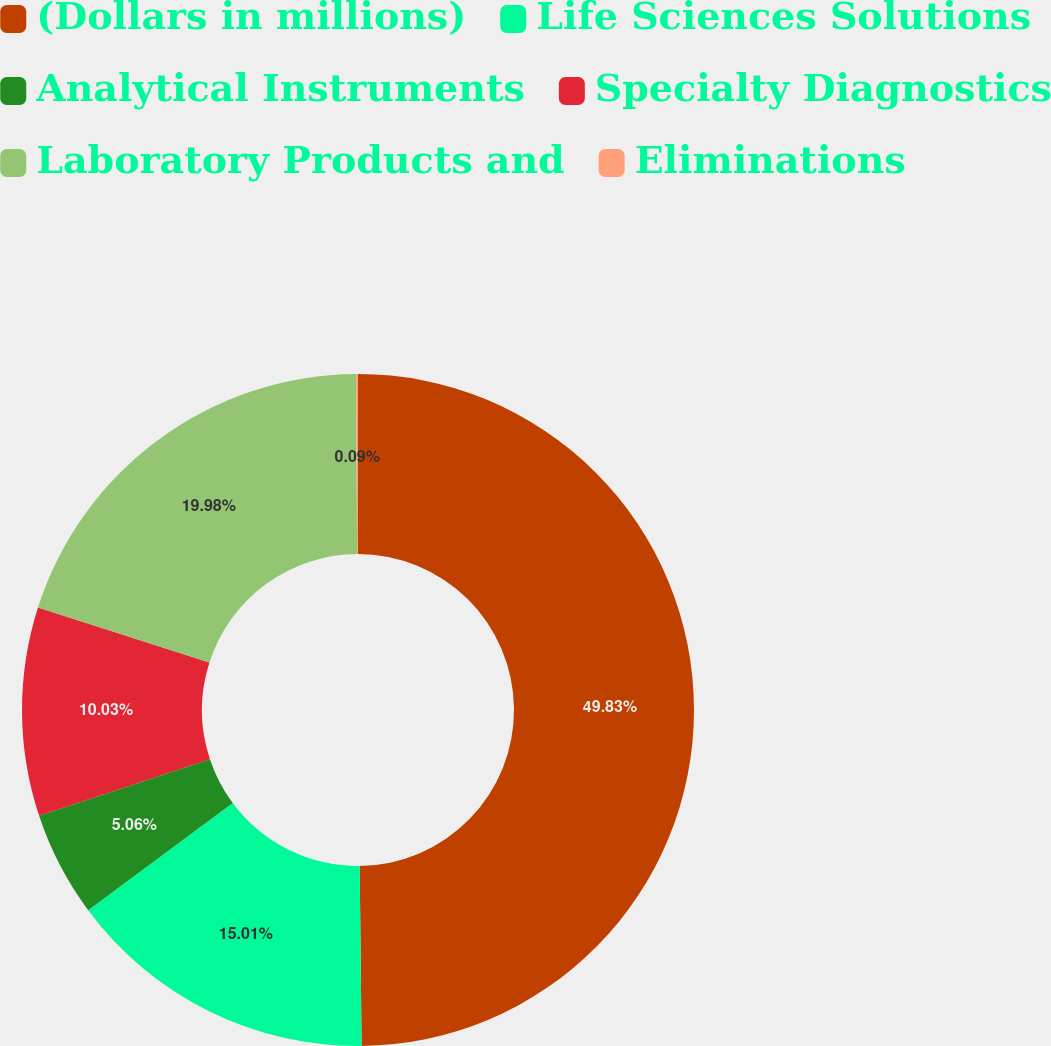<chart> <loc_0><loc_0><loc_500><loc_500><pie_chart><fcel>(Dollars in millions)<fcel>Life Sciences Solutions<fcel>Analytical Instruments<fcel>Specialty Diagnostics<fcel>Laboratory Products and<fcel>Eliminations<nl><fcel>49.83%<fcel>15.01%<fcel>5.06%<fcel>10.03%<fcel>19.98%<fcel>0.09%<nl></chart> 